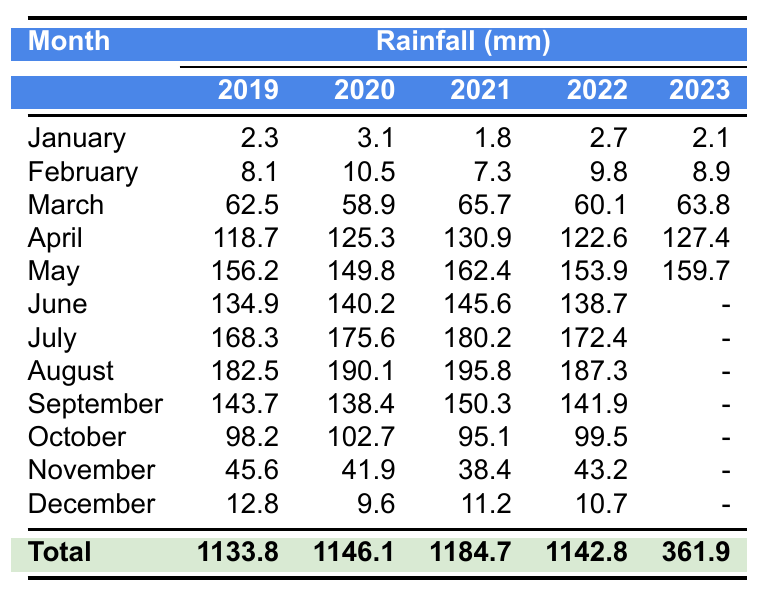What's the total rainfall recorded in Juba for the year 2019? To find the total rainfall for 2019, I add the monthly rainfall values: 2.3 + 8.1 + 62.5 + 118.7 + 156.2 + 134.9 + 168.3 + 182.5 + 143.7 + 98.2 + 45.6 + 12.8 = 1133.8 mm.
Answer: 1133.8 mm Which month in 2020 had the highest rainfall in Juba? I can see the monthly rainfall data for 2020: January (3.1), February (10.5), March (58.9), April (125.3), May (149.8), June (140.2), July (175.6), August (190.1), September (138.4), October (102.7), November (41.9), December (9.6). The highest value is 190.1 mm in August.
Answer: August What is the average rainfall for May over the years 2019 to 2023? The rainfall values for May are as follows: 2019 (156.2), 2020 (149.8), 2021 (162.4), 2022 (153.9), and 2023 (159.7). Adding these gives 156.2 + 149.8 + 162.4 + 153.9 + 159.7 = 782.0 mm. Dividing by 5 (the number of years): 782.0 / 5 = 156.4 mm.
Answer: 156.4 mm Did the rainfall in April increase from 2019 to 2023? The rainfall for April from 2019 to 2023 is as follows: 2019 (118.7), 2020 (125.3), 2021 (130.9), 2022 (122.6), and 2023 (127.4). I will compare these values: 2019 < 2020 < 2021 > 2022 < 2023, showing fluctuations without a consistent increase. Thus, it did not consistently increase.
Answer: No What’s the total rainfall recorded for the year 2021 compared to 2022? First, I find the total rainfall for each year. For 2021: 1.8 + 7.3 + 65.7 + 130.9 + 162.4 + 145.6 + 180.2 + 195.8 + 150.3 + 95.1 + 38.4 + 11.2 = 1184.7 mm. For 2022: 2.7 + 9.8 + 60.1 + 122.6 + 153.9 + 138.7 + 172.4 + 187.3 + 141.9 + 99.5 + 43.2 + 10.7 = 1142.8 mm. Comparing them, 1184.7 (2021) > 1142.8 (2022) indicates 2021 had more rainfall
Answer: 2021 had more rainfall What month had the lowest total rainfall over the five years? I review the total rainfall for each month: January (2.3 + 3.1 + 1.8 + 2.7 + 2.1 = 12.9), February (8.1 + 10.5 + 7.3 + 9.8 + 8.9 = 44.6), March (62.5 + 58.9 + 65.7 + 60.1 + 63.8 = 311.0), April (118.7 + 125.3 +130.9 + 122.6 + 127.4 = 625.0), etc. January has the lowest total of 12.9 mm.
Answer: January Was there a significant decrease in rainfall from 2020 to 2021 during the month of July? The rainfall values for July are 175.6 mm in 2020 and 180.2 mm in 2021. To determine if it was significant, I compare: 180.2 > 175.6, indicating an increase. Therefore, there was no decrease.
Answer: No How much difference is there in total rainfall between the years 2020 and 2023? The total rainfall for 2020 is 1146.1 mm and for 2023 is 361.9 mm. The difference is found by subtracting: 1146.1 - 361.9 = 784.2 mm, indicating that 2020 had significantly more rainfall.
Answer: 784.2 mm Which year had the highest rainfall in June? For June, I check the values: 2019 (134.9), 2020 (140.2), 2021 (145.6), 2022 (138.7), and 2023 is unavailable. Comparing these values, 145.6 mm in 2021 is the highest.
Answer: 2021 Which month typically has the highest rainfall in Juba? Referring to the data for each month, August (182.5 for 2019, 190.1 for 2020, 195.8 for 2021, 187.3 for 2022) shows consistently high rainfall compared to other months.
Answer: August 